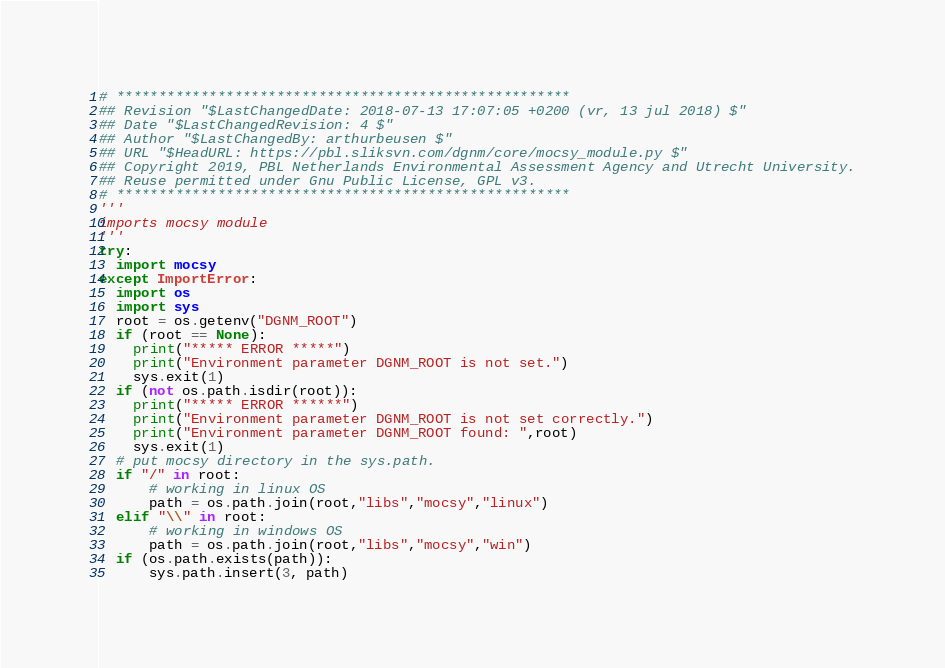<code> <loc_0><loc_0><loc_500><loc_500><_Python_># ******************************************************
## Revision "$LastChangedDate: 2018-07-13 17:07:05 +0200 (vr, 13 jul 2018) $"
## Date "$LastChangedRevision: 4 $"
## Author "$LastChangedBy: arthurbeusen $"
## URL "$HeadURL: https://pbl.sliksvn.com/dgnm/core/mocsy_module.py $"
## Copyright 2019, PBL Netherlands Environmental Assessment Agency and Utrecht University.
## Reuse permitted under Gnu Public License, GPL v3.
# ******************************************************
'''
imports mocsy module
'''
try: 
  import mocsy
except ImportError:
  import os
  import sys
  root = os.getenv("DGNM_ROOT")
  if (root == None):
    print("***** ERROR *****")
    print("Environment parameter DGNM_ROOT is not set.")
    sys.exit(1)
  if (not os.path.isdir(root)):
    print("***** ERROR ******")
    print("Environment parameter DGNM_ROOT is not set correctly.")
    print("Environment parameter DGNM_ROOT found: ",root)
    sys.exit(1)
  # put mocsy directory in the sys.path.
  if "/" in root:
      # working in linux OS
      path = os.path.join(root,"libs","mocsy","linux")
  elif "\\" in root:
      # working in windows OS
      path = os.path.join(root,"libs","mocsy","win")
  if (os.path.exists(path)):
      sys.path.insert(3, path)
</code> 